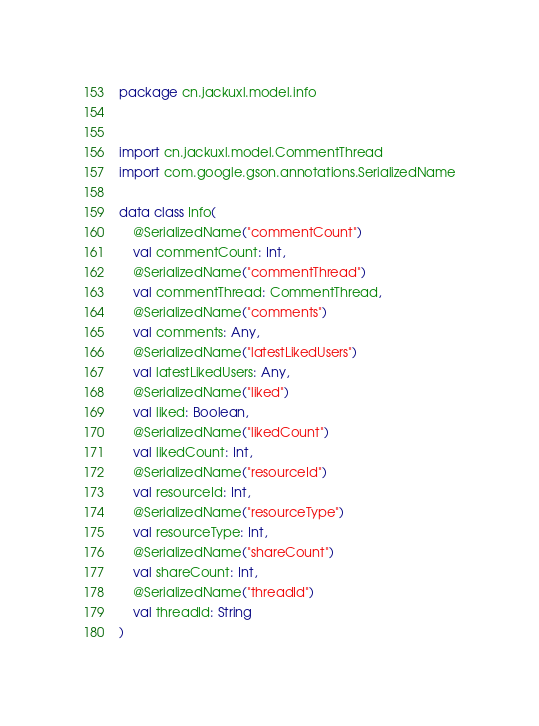Convert code to text. <code><loc_0><loc_0><loc_500><loc_500><_Kotlin_>package cn.jackuxl.model.info


import cn.jackuxl.model.CommentThread
import com.google.gson.annotations.SerializedName

data class Info(
    @SerializedName("commentCount")
    val commentCount: Int,
    @SerializedName("commentThread")
    val commentThread: CommentThread,
    @SerializedName("comments")
    val comments: Any,
    @SerializedName("latestLikedUsers")
    val latestLikedUsers: Any,
    @SerializedName("liked")
    val liked: Boolean,
    @SerializedName("likedCount")
    val likedCount: Int,
    @SerializedName("resourceId")
    val resourceId: Int,
    @SerializedName("resourceType")
    val resourceType: Int,
    @SerializedName("shareCount")
    val shareCount: Int,
    @SerializedName("threadId")
    val threadId: String
)</code> 